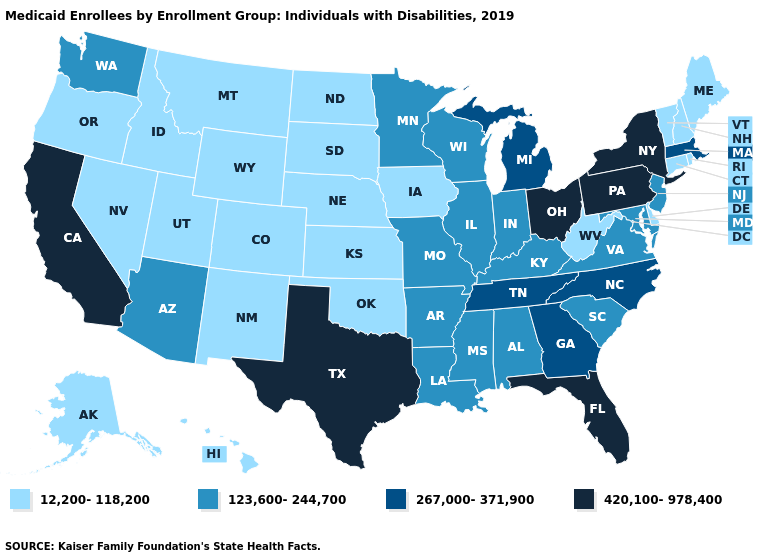Which states have the lowest value in the MidWest?
Keep it brief. Iowa, Kansas, Nebraska, North Dakota, South Dakota. Among the states that border Michigan , does Indiana have the lowest value?
Quick response, please. Yes. Does Alaska have the highest value in the USA?
Quick response, please. No. Among the states that border Rhode Island , does Massachusetts have the highest value?
Write a very short answer. Yes. What is the value of Nevada?
Be succinct. 12,200-118,200. What is the value of South Carolina?
Write a very short answer. 123,600-244,700. Does Idaho have the highest value in the West?
Answer briefly. No. Does the first symbol in the legend represent the smallest category?
Short answer required. Yes. Which states have the lowest value in the Northeast?
Quick response, please. Connecticut, Maine, New Hampshire, Rhode Island, Vermont. What is the value of Nebraska?
Quick response, please. 12,200-118,200. Does the first symbol in the legend represent the smallest category?
Answer briefly. Yes. What is the highest value in the Northeast ?
Keep it brief. 420,100-978,400. Among the states that border Arkansas , which have the lowest value?
Write a very short answer. Oklahoma. Which states have the lowest value in the USA?
Quick response, please. Alaska, Colorado, Connecticut, Delaware, Hawaii, Idaho, Iowa, Kansas, Maine, Montana, Nebraska, Nevada, New Hampshire, New Mexico, North Dakota, Oklahoma, Oregon, Rhode Island, South Dakota, Utah, Vermont, West Virginia, Wyoming. Which states have the highest value in the USA?
Short answer required. California, Florida, New York, Ohio, Pennsylvania, Texas. 